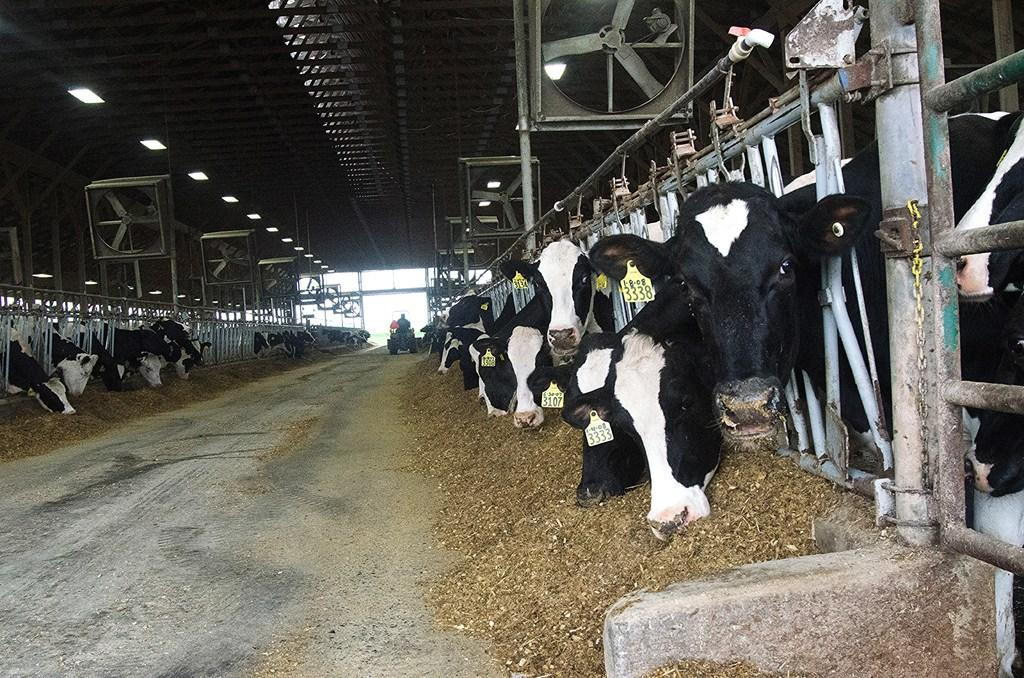What animals are present in the image? There are cows in the image. What colors are the cows? The cows are black and white in color. What is the person in the image doing? The person is sitting in a vehicle in the image. What type of lights can be seen in the image? There are lights visible in the image. What structures are present in the image? There are poles in the image. What type of equipment is visible in the image? There are exhaust fans in the image. What is the color of the sky in the image? The sky is white in color. What type of heart is visible in the image? There is no heart present in the image. What material is the steel used for in the image? There is no steel present in the image. 